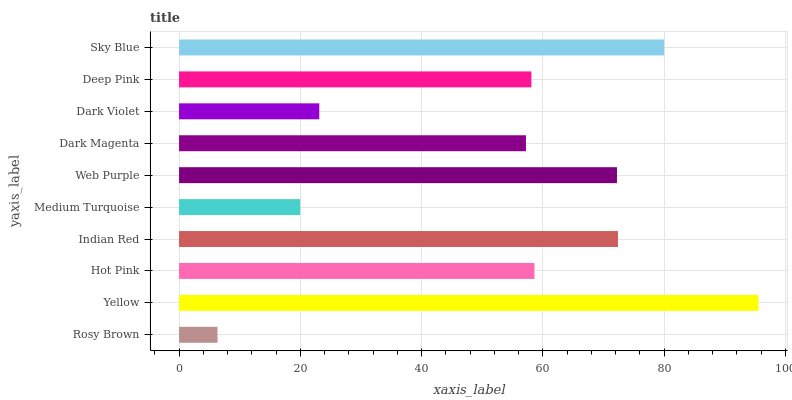Is Rosy Brown the minimum?
Answer yes or no. Yes. Is Yellow the maximum?
Answer yes or no. Yes. Is Hot Pink the minimum?
Answer yes or no. No. Is Hot Pink the maximum?
Answer yes or no. No. Is Yellow greater than Hot Pink?
Answer yes or no. Yes. Is Hot Pink less than Yellow?
Answer yes or no. Yes. Is Hot Pink greater than Yellow?
Answer yes or no. No. Is Yellow less than Hot Pink?
Answer yes or no. No. Is Hot Pink the high median?
Answer yes or no. Yes. Is Deep Pink the low median?
Answer yes or no. Yes. Is Rosy Brown the high median?
Answer yes or no. No. Is Sky Blue the low median?
Answer yes or no. No. 